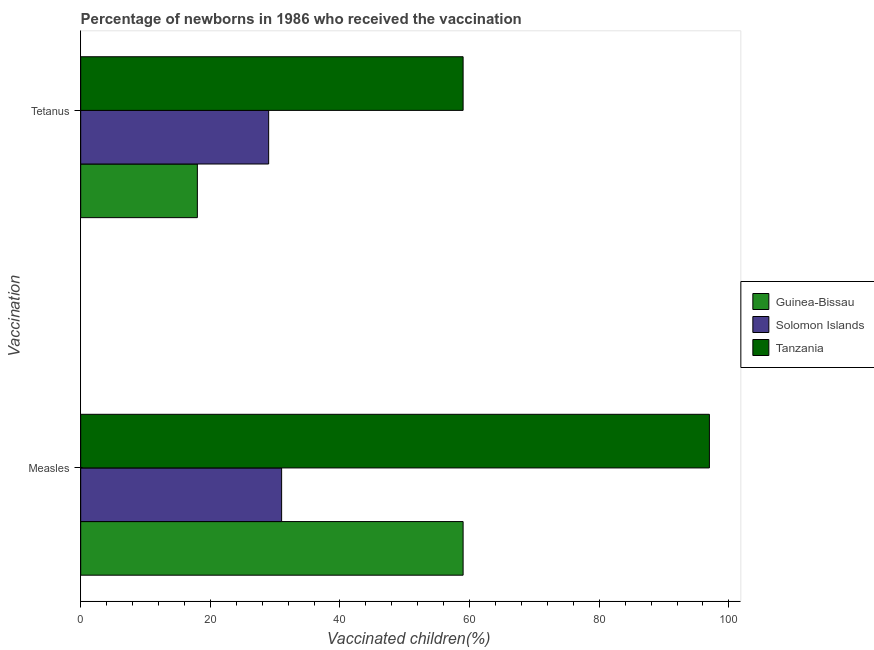How many groups of bars are there?
Make the answer very short. 2. Are the number of bars per tick equal to the number of legend labels?
Your answer should be compact. Yes. Are the number of bars on each tick of the Y-axis equal?
Ensure brevity in your answer.  Yes. What is the label of the 1st group of bars from the top?
Make the answer very short. Tetanus. What is the percentage of newborns who received vaccination for tetanus in Tanzania?
Provide a short and direct response. 59. Across all countries, what is the maximum percentage of newborns who received vaccination for measles?
Provide a short and direct response. 97. Across all countries, what is the minimum percentage of newborns who received vaccination for measles?
Ensure brevity in your answer.  31. In which country was the percentage of newborns who received vaccination for tetanus maximum?
Offer a terse response. Tanzania. In which country was the percentage of newborns who received vaccination for tetanus minimum?
Your answer should be very brief. Guinea-Bissau. What is the total percentage of newborns who received vaccination for tetanus in the graph?
Offer a very short reply. 106. What is the difference between the percentage of newborns who received vaccination for measles in Guinea-Bissau and that in Solomon Islands?
Your answer should be compact. 28. What is the difference between the percentage of newborns who received vaccination for measles in Solomon Islands and the percentage of newborns who received vaccination for tetanus in Guinea-Bissau?
Offer a terse response. 13. What is the average percentage of newborns who received vaccination for measles per country?
Make the answer very short. 62.33. What is the difference between the percentage of newborns who received vaccination for measles and percentage of newborns who received vaccination for tetanus in Tanzania?
Keep it short and to the point. 38. In how many countries, is the percentage of newborns who received vaccination for measles greater than 32 %?
Ensure brevity in your answer.  2. What is the ratio of the percentage of newborns who received vaccination for measles in Guinea-Bissau to that in Solomon Islands?
Offer a very short reply. 1.9. Is the percentage of newborns who received vaccination for tetanus in Guinea-Bissau less than that in Tanzania?
Ensure brevity in your answer.  Yes. In how many countries, is the percentage of newborns who received vaccination for measles greater than the average percentage of newborns who received vaccination for measles taken over all countries?
Offer a terse response. 1. What does the 1st bar from the top in Measles represents?
Offer a very short reply. Tanzania. What does the 3rd bar from the bottom in Measles represents?
Ensure brevity in your answer.  Tanzania. How are the legend labels stacked?
Your response must be concise. Vertical. What is the title of the graph?
Keep it short and to the point. Percentage of newborns in 1986 who received the vaccination. What is the label or title of the X-axis?
Keep it short and to the point. Vaccinated children(%)
. What is the label or title of the Y-axis?
Provide a succinct answer. Vaccination. What is the Vaccinated children(%)
 of Guinea-Bissau in Measles?
Your answer should be compact. 59. What is the Vaccinated children(%)
 of Tanzania in Measles?
Your answer should be very brief. 97. Across all Vaccination, what is the maximum Vaccinated children(%)
 in Guinea-Bissau?
Your answer should be very brief. 59. Across all Vaccination, what is the maximum Vaccinated children(%)
 in Solomon Islands?
Your answer should be very brief. 31. Across all Vaccination, what is the maximum Vaccinated children(%)
 in Tanzania?
Your response must be concise. 97. Across all Vaccination, what is the minimum Vaccinated children(%)
 in Guinea-Bissau?
Your answer should be very brief. 18. Across all Vaccination, what is the minimum Vaccinated children(%)
 in Solomon Islands?
Your answer should be very brief. 29. What is the total Vaccinated children(%)
 in Solomon Islands in the graph?
Give a very brief answer. 60. What is the total Vaccinated children(%)
 in Tanzania in the graph?
Ensure brevity in your answer.  156. What is the difference between the Vaccinated children(%)
 in Guinea-Bissau in Measles and that in Tetanus?
Your answer should be compact. 41. What is the difference between the Vaccinated children(%)
 in Guinea-Bissau in Measles and the Vaccinated children(%)
 in Tanzania in Tetanus?
Provide a succinct answer. 0. What is the average Vaccinated children(%)
 in Guinea-Bissau per Vaccination?
Make the answer very short. 38.5. What is the average Vaccinated children(%)
 of Solomon Islands per Vaccination?
Offer a very short reply. 30. What is the average Vaccinated children(%)
 in Tanzania per Vaccination?
Your answer should be compact. 78. What is the difference between the Vaccinated children(%)
 of Guinea-Bissau and Vaccinated children(%)
 of Solomon Islands in Measles?
Offer a terse response. 28. What is the difference between the Vaccinated children(%)
 of Guinea-Bissau and Vaccinated children(%)
 of Tanzania in Measles?
Keep it short and to the point. -38. What is the difference between the Vaccinated children(%)
 of Solomon Islands and Vaccinated children(%)
 of Tanzania in Measles?
Provide a short and direct response. -66. What is the difference between the Vaccinated children(%)
 in Guinea-Bissau and Vaccinated children(%)
 in Solomon Islands in Tetanus?
Offer a very short reply. -11. What is the difference between the Vaccinated children(%)
 of Guinea-Bissau and Vaccinated children(%)
 of Tanzania in Tetanus?
Your response must be concise. -41. What is the ratio of the Vaccinated children(%)
 of Guinea-Bissau in Measles to that in Tetanus?
Make the answer very short. 3.28. What is the ratio of the Vaccinated children(%)
 in Solomon Islands in Measles to that in Tetanus?
Make the answer very short. 1.07. What is the ratio of the Vaccinated children(%)
 of Tanzania in Measles to that in Tetanus?
Offer a terse response. 1.64. What is the difference between the highest and the second highest Vaccinated children(%)
 in Guinea-Bissau?
Your response must be concise. 41. What is the difference between the highest and the lowest Vaccinated children(%)
 of Solomon Islands?
Offer a very short reply. 2. 